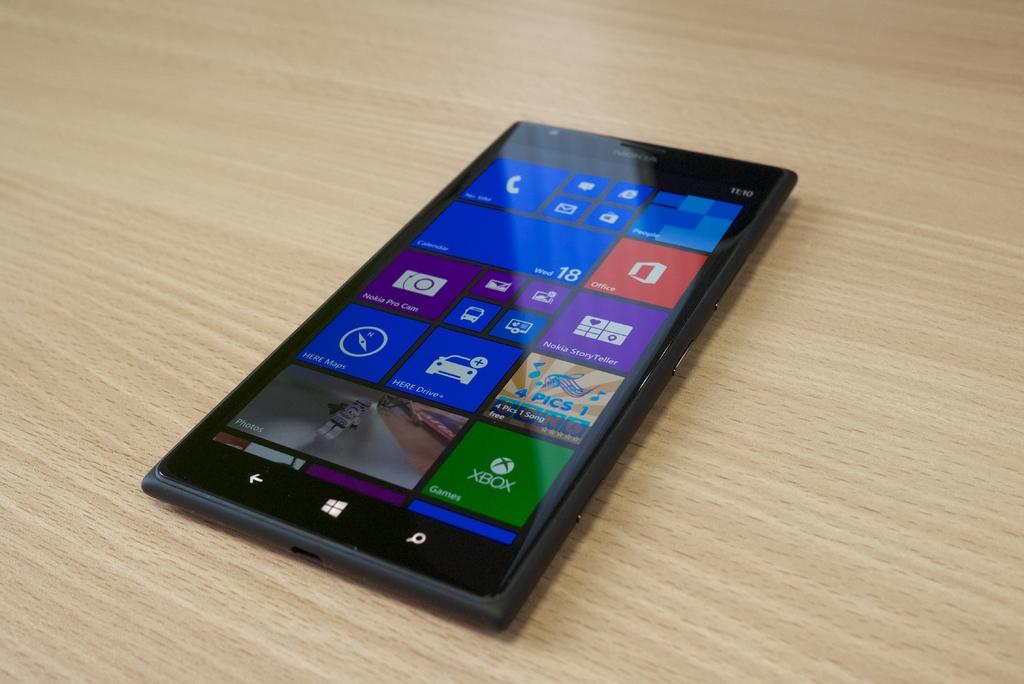<image>
Render a clear and concise summary of the photo. the word Nokia is on the phone that has many apps 